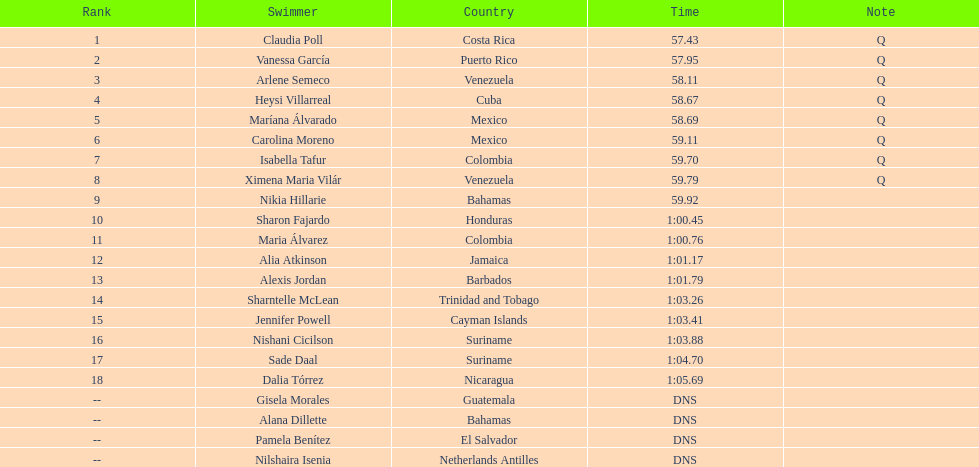How many mexican swimmers ranked in the top 10? 2. 